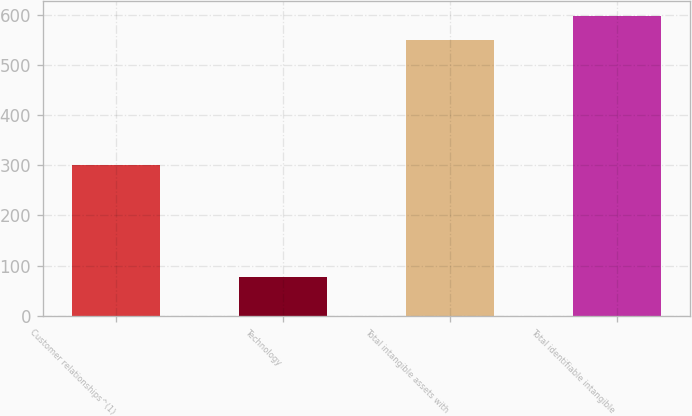Convert chart to OTSL. <chart><loc_0><loc_0><loc_500><loc_500><bar_chart><fcel>Customer relationships^(1)<fcel>Technology<fcel>Total intangible assets with<fcel>Total identifiable intangible<nl><fcel>299.9<fcel>78.1<fcel>549.8<fcel>596.97<nl></chart> 